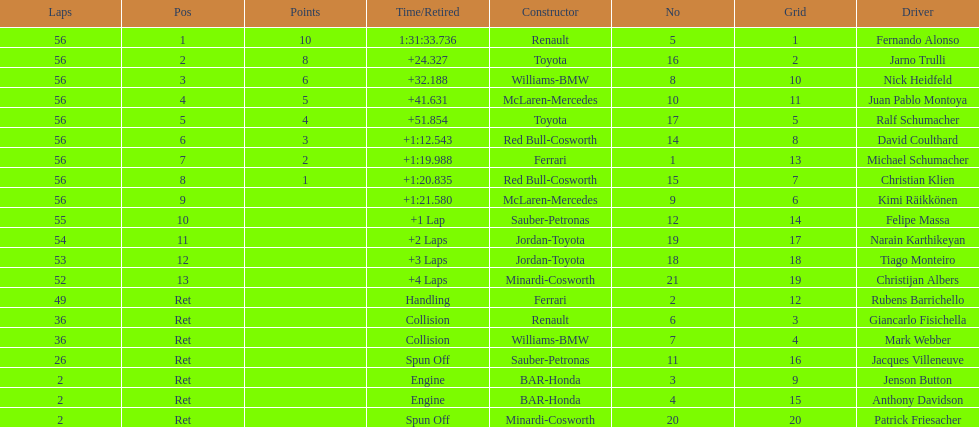What driver finished first? Fernando Alonso. 